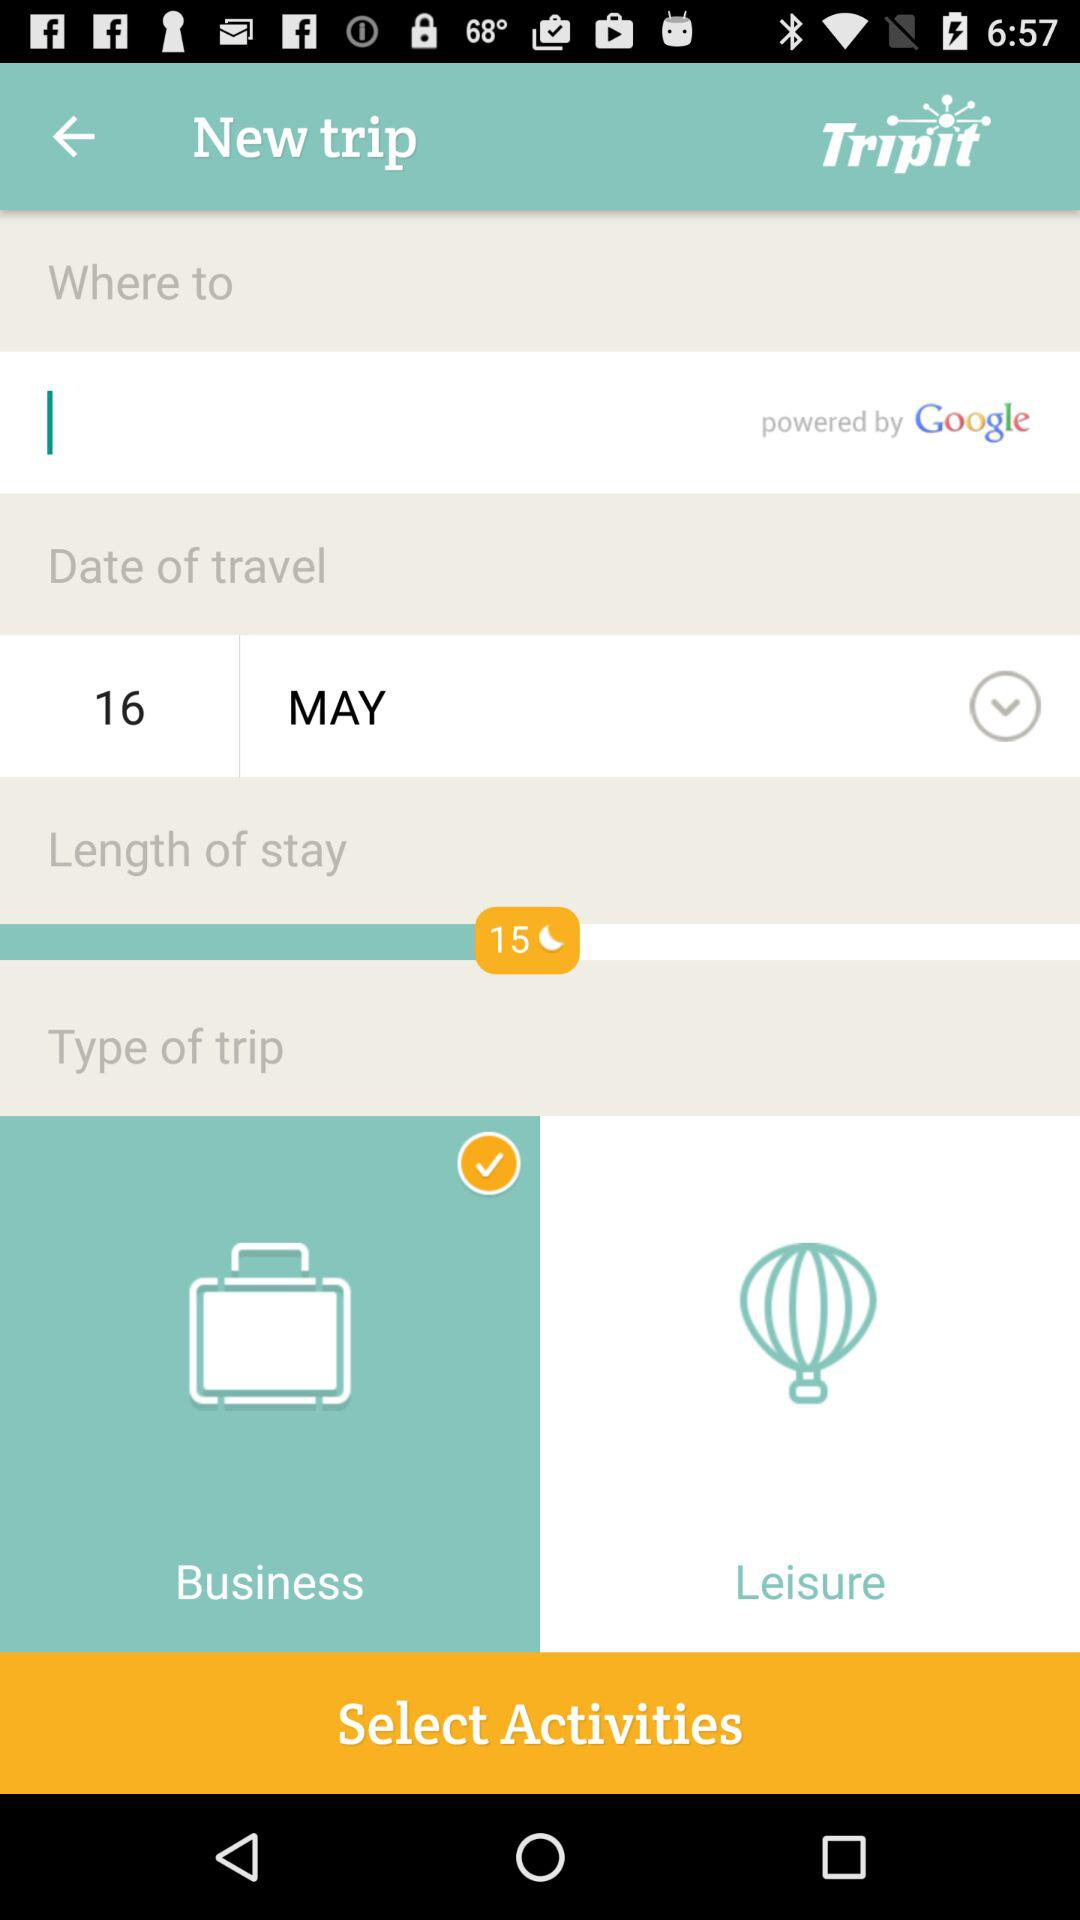What is the date of travel? The date of travel is May 16. 